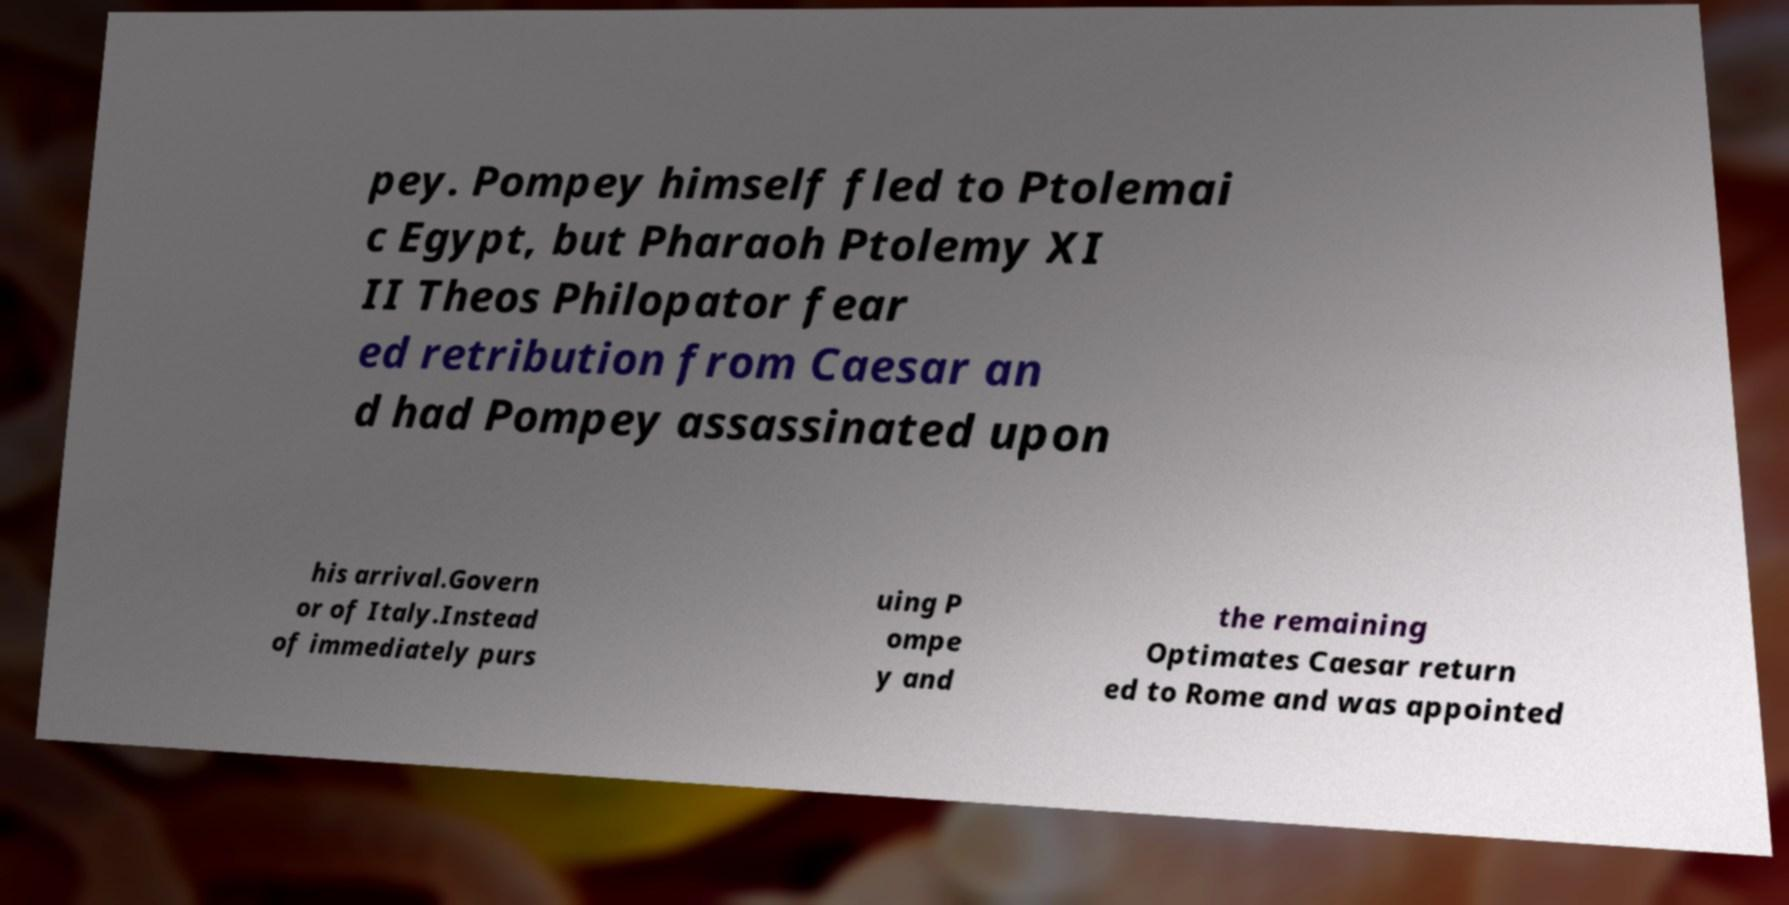Please identify and transcribe the text found in this image. pey. Pompey himself fled to Ptolemai c Egypt, but Pharaoh Ptolemy XI II Theos Philopator fear ed retribution from Caesar an d had Pompey assassinated upon his arrival.Govern or of Italy.Instead of immediately purs uing P ompe y and the remaining Optimates Caesar return ed to Rome and was appointed 